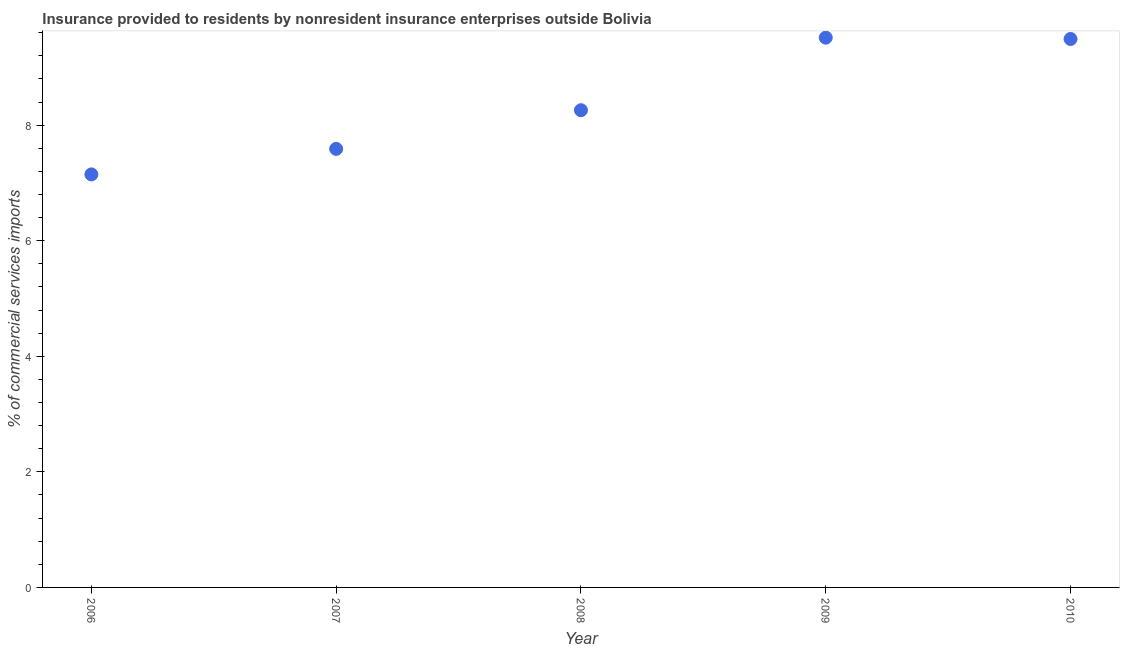What is the insurance provided by non-residents in 2008?
Make the answer very short. 8.26. Across all years, what is the maximum insurance provided by non-residents?
Provide a short and direct response. 9.51. Across all years, what is the minimum insurance provided by non-residents?
Your answer should be compact. 7.15. In which year was the insurance provided by non-residents maximum?
Offer a very short reply. 2009. What is the sum of the insurance provided by non-residents?
Give a very brief answer. 42. What is the difference between the insurance provided by non-residents in 2006 and 2007?
Your response must be concise. -0.44. What is the average insurance provided by non-residents per year?
Provide a succinct answer. 8.4. What is the median insurance provided by non-residents?
Offer a very short reply. 8.26. In how many years, is the insurance provided by non-residents greater than 7.2 %?
Your answer should be very brief. 4. Do a majority of the years between 2006 and 2007 (inclusive) have insurance provided by non-residents greater than 1.2000000000000002 %?
Give a very brief answer. Yes. What is the ratio of the insurance provided by non-residents in 2006 to that in 2007?
Your answer should be compact. 0.94. Is the insurance provided by non-residents in 2006 less than that in 2010?
Your answer should be very brief. Yes. What is the difference between the highest and the second highest insurance provided by non-residents?
Offer a terse response. 0.02. Is the sum of the insurance provided by non-residents in 2008 and 2009 greater than the maximum insurance provided by non-residents across all years?
Your answer should be very brief. Yes. What is the difference between the highest and the lowest insurance provided by non-residents?
Your answer should be compact. 2.37. Does the insurance provided by non-residents monotonically increase over the years?
Offer a very short reply. No. Are the values on the major ticks of Y-axis written in scientific E-notation?
Ensure brevity in your answer.  No. Does the graph contain any zero values?
Your response must be concise. No. What is the title of the graph?
Ensure brevity in your answer.  Insurance provided to residents by nonresident insurance enterprises outside Bolivia. What is the label or title of the Y-axis?
Keep it short and to the point. % of commercial services imports. What is the % of commercial services imports in 2006?
Ensure brevity in your answer.  7.15. What is the % of commercial services imports in 2007?
Give a very brief answer. 7.59. What is the % of commercial services imports in 2008?
Give a very brief answer. 8.26. What is the % of commercial services imports in 2009?
Your answer should be compact. 9.51. What is the % of commercial services imports in 2010?
Offer a very short reply. 9.49. What is the difference between the % of commercial services imports in 2006 and 2007?
Keep it short and to the point. -0.44. What is the difference between the % of commercial services imports in 2006 and 2008?
Provide a succinct answer. -1.11. What is the difference between the % of commercial services imports in 2006 and 2009?
Ensure brevity in your answer.  -2.37. What is the difference between the % of commercial services imports in 2006 and 2010?
Ensure brevity in your answer.  -2.34. What is the difference between the % of commercial services imports in 2007 and 2008?
Your answer should be compact. -0.67. What is the difference between the % of commercial services imports in 2007 and 2009?
Provide a succinct answer. -1.92. What is the difference between the % of commercial services imports in 2007 and 2010?
Your answer should be compact. -1.9. What is the difference between the % of commercial services imports in 2008 and 2009?
Offer a very short reply. -1.26. What is the difference between the % of commercial services imports in 2008 and 2010?
Your answer should be compact. -1.23. What is the difference between the % of commercial services imports in 2009 and 2010?
Offer a very short reply. 0.02. What is the ratio of the % of commercial services imports in 2006 to that in 2007?
Provide a succinct answer. 0.94. What is the ratio of the % of commercial services imports in 2006 to that in 2008?
Your answer should be compact. 0.87. What is the ratio of the % of commercial services imports in 2006 to that in 2009?
Provide a short and direct response. 0.75. What is the ratio of the % of commercial services imports in 2006 to that in 2010?
Offer a terse response. 0.75. What is the ratio of the % of commercial services imports in 2007 to that in 2008?
Your answer should be very brief. 0.92. What is the ratio of the % of commercial services imports in 2007 to that in 2009?
Make the answer very short. 0.8. What is the ratio of the % of commercial services imports in 2007 to that in 2010?
Your answer should be very brief. 0.8. What is the ratio of the % of commercial services imports in 2008 to that in 2009?
Provide a short and direct response. 0.87. What is the ratio of the % of commercial services imports in 2008 to that in 2010?
Provide a succinct answer. 0.87. 